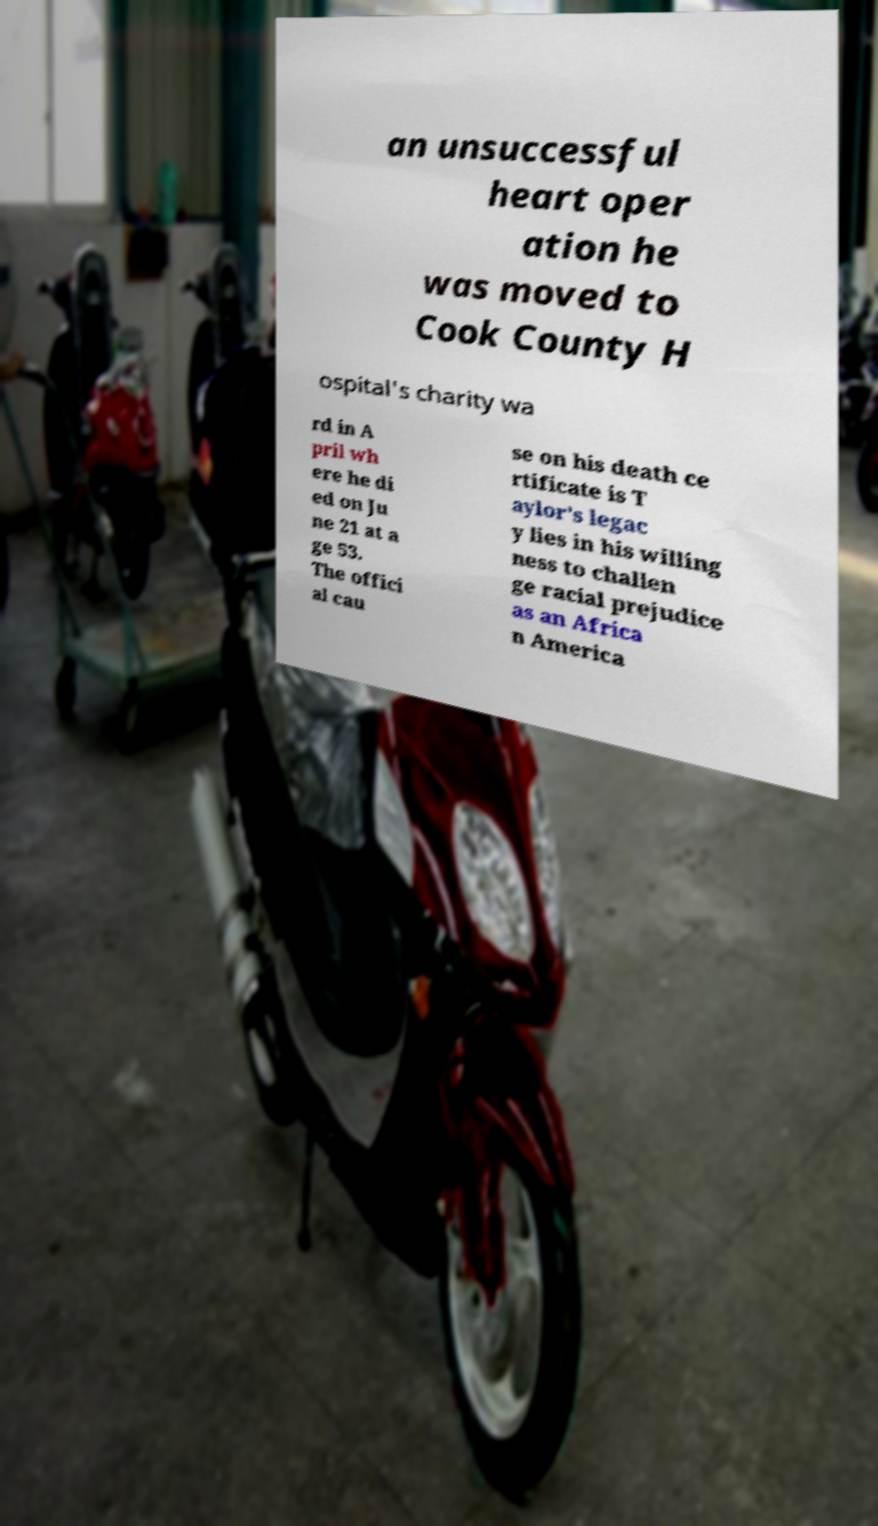Can you read and provide the text displayed in the image?This photo seems to have some interesting text. Can you extract and type it out for me? an unsuccessful heart oper ation he was moved to Cook County H ospital's charity wa rd in A pril wh ere he di ed on Ju ne 21 at a ge 53. The offici al cau se on his death ce rtificate is T aylor's legac y lies in his willing ness to challen ge racial prejudice as an Africa n America 